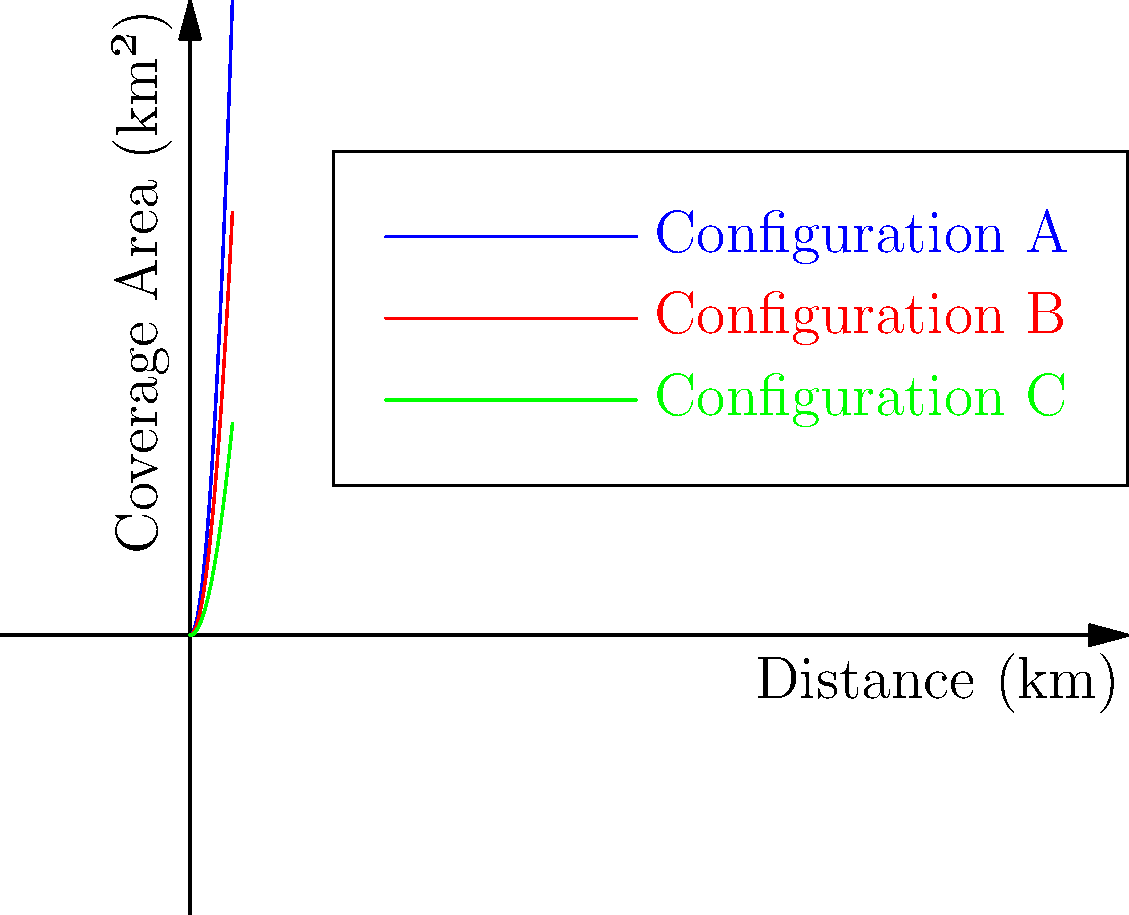The graph shows the coverage area as a function of distance for three different cell tower configurations (A, B, and C). At what distance does Configuration A provide twice the coverage area of Configuration C? To solve this problem, we need to follow these steps:

1. Identify the equations for each configuration:
   Configuration A: $y = 3x^2$
   Configuration B: $y = 2x^2$
   Configuration C: $y = x^2$

2. Set up an equation where Configuration A's coverage is twice that of Configuration C:
   $3x^2 = 2(x^2)$

3. Solve the equation:
   $3x^2 = 2x^2$
   $x^2 = 0$
   $x = 0$

4. However, $x = 0$ doesn't provide a meaningful answer for our context. We need to find where the ratio of the coverage areas is 2:1.

5. Set up the ratio equation:
   $\frac{3x^2}{x^2} = 2$

6. Solve this equation:
   $3 = 2$

This is true for all non-zero values of $x$. Therefore, Configuration A always provides twice the coverage area of Configuration C, regardless of the distance.

To verify, we can check at any distance, say $x = 2$:
Configuration A: $3(2^2) = 12$ km²
Configuration C: $2^2 = 4$ km²

Indeed, $12$ is twice $4$, confirming our conclusion.
Answer: At all distances 